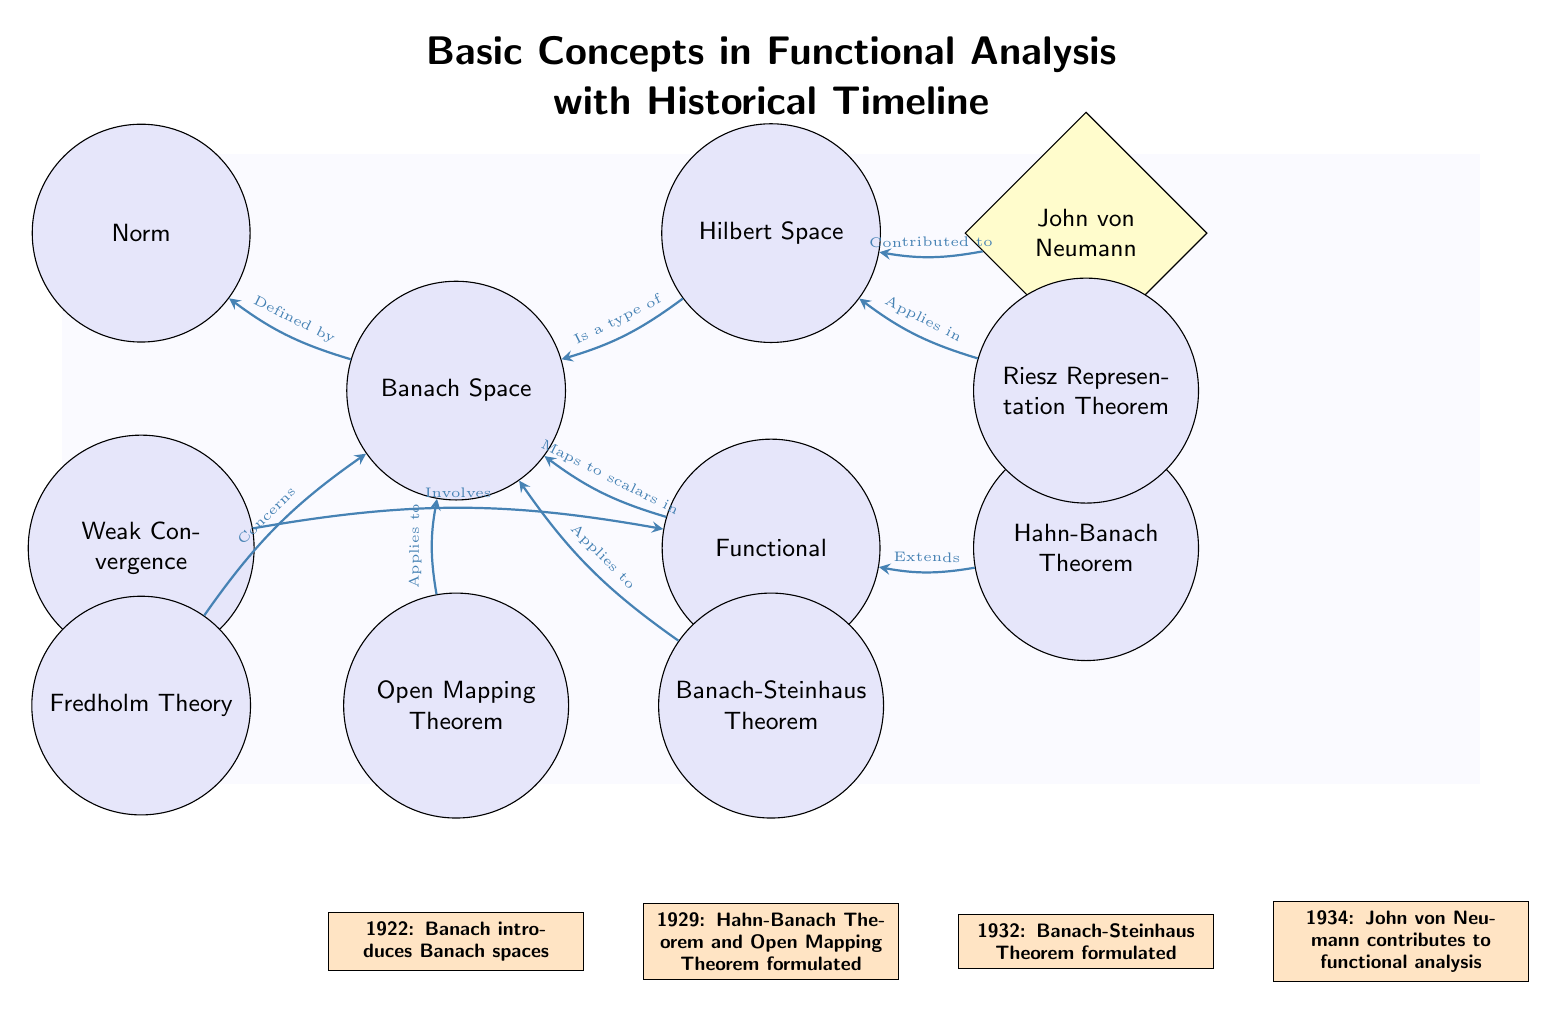What concept is defined by the Norm? The diagram indicates that the concept of Banach Space is defined by Norm, as an edge is drawn from Norm to Banach Space with the label "Defined by."
Answer: Banach Space How many concepts are applied to the Banach Space? By examining the edges connected to Banach Space, we see that three concepts (Open Mapping Theorem, Banach-Steinhaus Theorem, Fredholm Theory) apply to it, confirmed by the appropriate directional edges.
Answer: 3 Who contributed to the Hilbert Space? From the diagram, we can see that John von Neumann is connected to the Hilbert Space with an edge labeled "Contributed to," clearly indicating his involvement.
Answer: John von Neumann What theorem extends the concept of Functional? The diagram shows that the Hahn-Banach Theorem extends the concept of Functional, indicated by the directed edge from Hahn-Banach Theorem to Functional labeled "Extends."
Answer: Hahn-Banach Theorem What year did Banach introduce Banach spaces? The timeline at the bottom indicates that Banach introduced Banach spaces in the year 1922, providing a clear historical reference in functional analysis.
Answer: 1922 Which theorem applies in the Hilbert Space? The diagram shows that the Riesz Representation Theorem applies in Hilbert Space, as indicated by the edge connecting Riesz Representation Theorem to Hilbert Space labeled "Applies in."
Answer: Riesz Representation Theorem What is the relationship between Weak Convergence and Functional? The diagram illustrates that Weak Convergence involves Functional, with an edge labeled "Involves" connecting the two, indicating their relationship.
Answer: Involves List two concepts that are types of Banach Space. The diagram indicates that Norm and Hilbert Space are closely related to Banach Space, as Norm defines Banach Space and Hilbert Space is described as a type of Banach Space.
Answer: Norm, Hilbert Space How many steps reflect the historical progression in the diagram? By counting the timeline events listed in the diagram, we find four specific steps, as indicated by the historical milestones outlined beneath the concepts.
Answer: 4 